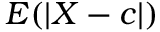Convert formula to latex. <formula><loc_0><loc_0><loc_500><loc_500>E ( \left | X - c \right | )</formula> 